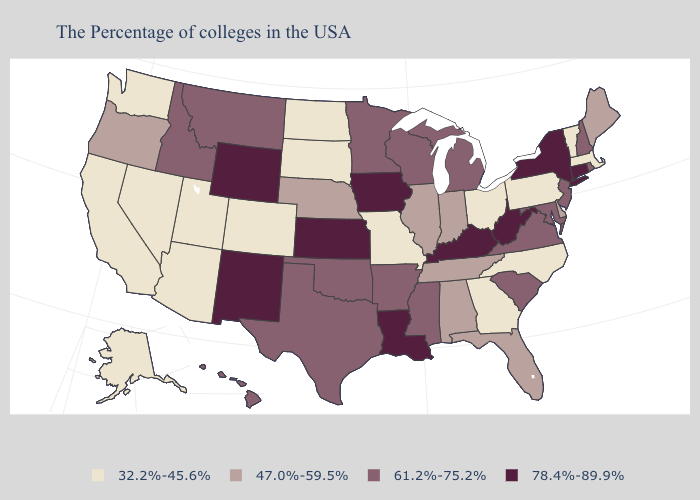Name the states that have a value in the range 61.2%-75.2%?
Quick response, please. Rhode Island, New Hampshire, New Jersey, Maryland, Virginia, South Carolina, Michigan, Wisconsin, Mississippi, Arkansas, Minnesota, Oklahoma, Texas, Montana, Idaho, Hawaii. Name the states that have a value in the range 78.4%-89.9%?
Give a very brief answer. Connecticut, New York, West Virginia, Kentucky, Louisiana, Iowa, Kansas, Wyoming, New Mexico. Name the states that have a value in the range 47.0%-59.5%?
Be succinct. Maine, Delaware, Florida, Indiana, Alabama, Tennessee, Illinois, Nebraska, Oregon. What is the lowest value in the USA?
Answer briefly. 32.2%-45.6%. Name the states that have a value in the range 47.0%-59.5%?
Short answer required. Maine, Delaware, Florida, Indiana, Alabama, Tennessee, Illinois, Nebraska, Oregon. Name the states that have a value in the range 78.4%-89.9%?
Quick response, please. Connecticut, New York, West Virginia, Kentucky, Louisiana, Iowa, Kansas, Wyoming, New Mexico. What is the highest value in the MidWest ?
Concise answer only. 78.4%-89.9%. Is the legend a continuous bar?
Quick response, please. No. What is the highest value in the MidWest ?
Write a very short answer. 78.4%-89.9%. Does Maine have the same value as Alabama?
Short answer required. Yes. What is the value of Montana?
Be succinct. 61.2%-75.2%. Does West Virginia have the highest value in the South?
Quick response, please. Yes. Does Alaska have the same value as Nevada?
Keep it brief. Yes. Name the states that have a value in the range 47.0%-59.5%?
Be succinct. Maine, Delaware, Florida, Indiana, Alabama, Tennessee, Illinois, Nebraska, Oregon. 